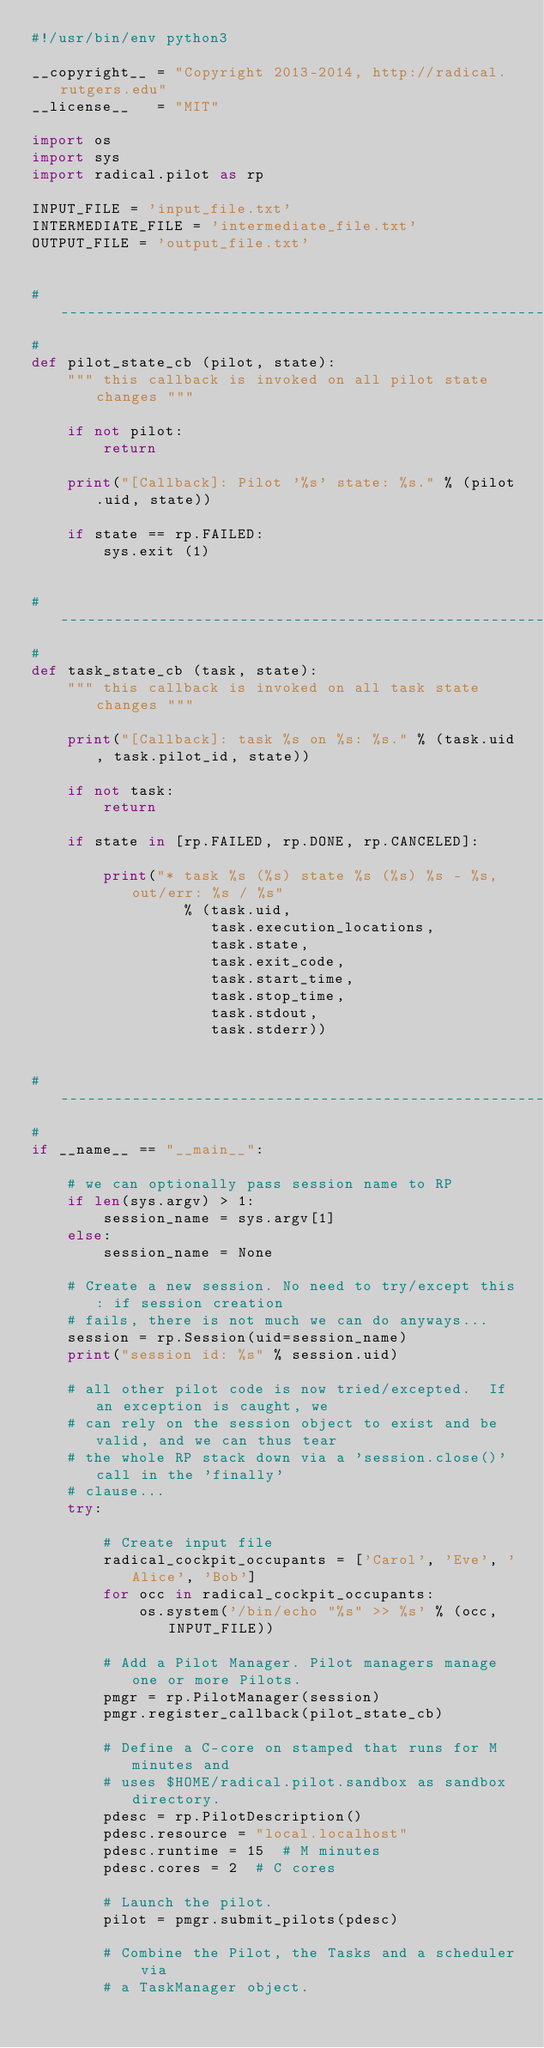<code> <loc_0><loc_0><loc_500><loc_500><_Python_>#!/usr/bin/env python3

__copyright__ = "Copyright 2013-2014, http://radical.rutgers.edu"
__license__   = "MIT"

import os
import sys
import radical.pilot as rp

INPUT_FILE = 'input_file.txt'
INTERMEDIATE_FILE = 'intermediate_file.txt'
OUTPUT_FILE = 'output_file.txt'


# ------------------------------------------------------------------------------
#
def pilot_state_cb (pilot, state):
    """ this callback is invoked on all pilot state changes """

    if not pilot:
        return

    print("[Callback]: Pilot '%s' state: %s." % (pilot.uid, state))

    if state == rp.FAILED:
        sys.exit (1)


# ------------------------------------------------------------------------------
#
def task_state_cb (task, state):
    """ this callback is invoked on all task state changes """

    print("[Callback]: task %s on %s: %s." % (task.uid, task.pilot_id, state))

    if not task:
        return

    if state in [rp.FAILED, rp.DONE, rp.CANCELED]:

        print("* task %s (%s) state %s (%s) %s - %s, out/err: %s / %s"
                 % (task.uid,
                    task.execution_locations,
                    task.state,
                    task.exit_code,
                    task.start_time,
                    task.stop_time,
                    task.stdout,
                    task.stderr))


# ------------------------------------------------------------------------------
#
if __name__ == "__main__":

    # we can optionally pass session name to RP
    if len(sys.argv) > 1:
        session_name = sys.argv[1]
    else:
        session_name = None

    # Create a new session. No need to try/except this: if session creation
    # fails, there is not much we can do anyways...
    session = rp.Session(uid=session_name)
    print("session id: %s" % session.uid)

    # all other pilot code is now tried/excepted.  If an exception is caught, we
    # can rely on the session object to exist and be valid, and we can thus tear
    # the whole RP stack down via a 'session.close()' call in the 'finally'
    # clause...
    try:

        # Create input file
        radical_cockpit_occupants = ['Carol', 'Eve', 'Alice', 'Bob']
        for occ in radical_cockpit_occupants:
            os.system('/bin/echo "%s" >> %s' % (occ, INPUT_FILE))

        # Add a Pilot Manager. Pilot managers manage one or more Pilots.
        pmgr = rp.PilotManager(session)
        pmgr.register_callback(pilot_state_cb)

        # Define a C-core on stamped that runs for M minutes and
        # uses $HOME/radical.pilot.sandbox as sandbox directory.
        pdesc = rp.PilotDescription()
        pdesc.resource = "local.localhost"
        pdesc.runtime = 15  # M minutes
        pdesc.cores = 2  # C cores

        # Launch the pilot.
        pilot = pmgr.submit_pilots(pdesc)

        # Combine the Pilot, the Tasks and a scheduler via
        # a TaskManager object.</code> 